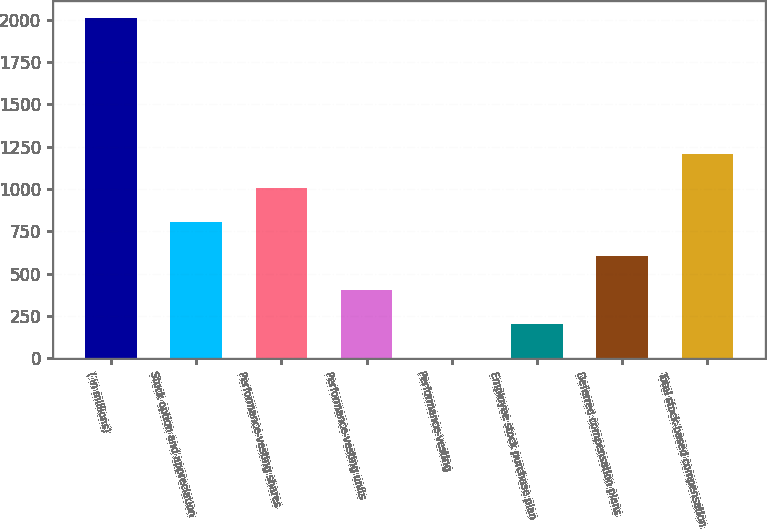Convert chart. <chart><loc_0><loc_0><loc_500><loc_500><bar_chart><fcel>( in millions)<fcel>Stock option and appreciation<fcel>Performance-vesting shares<fcel>Performance-vesting units<fcel>Performance-vesting<fcel>Employee stock purchase plan<fcel>Deferred compensation plans<fcel>Total stock-based compensation<nl><fcel>2012<fcel>804.86<fcel>1006.05<fcel>402.48<fcel>0.1<fcel>201.29<fcel>603.67<fcel>1207.24<nl></chart> 